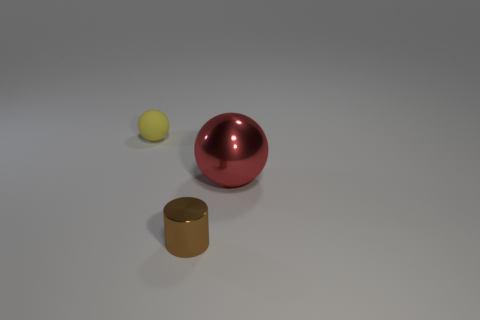Add 2 large metallic balls. How many objects exist? 5 Subtract all cylinders. How many objects are left? 2 Add 3 cyan metal blocks. How many cyan metal blocks exist? 3 Subtract 0 purple spheres. How many objects are left? 3 Subtract all tiny purple rubber cubes. Subtract all red spheres. How many objects are left? 2 Add 2 small brown cylinders. How many small brown cylinders are left? 3 